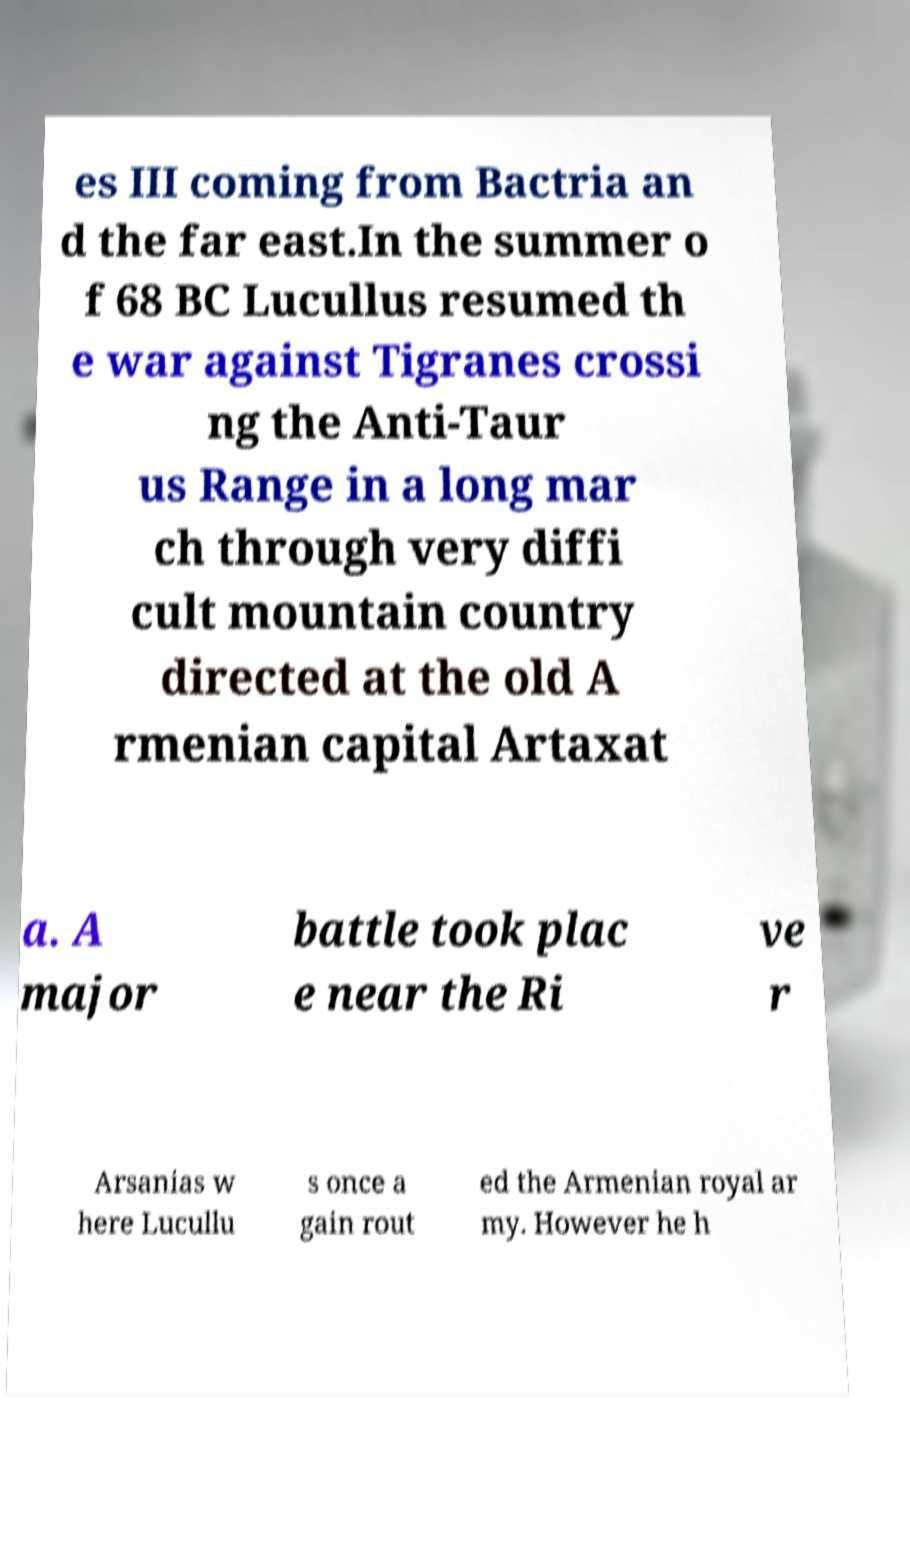Could you extract and type out the text from this image? es III coming from Bactria an d the far east.In the summer o f 68 BC Lucullus resumed th e war against Tigranes crossi ng the Anti-Taur us Range in a long mar ch through very diffi cult mountain country directed at the old A rmenian capital Artaxat a. A major battle took plac e near the Ri ve r Arsanias w here Lucullu s once a gain rout ed the Armenian royal ar my. However he h 